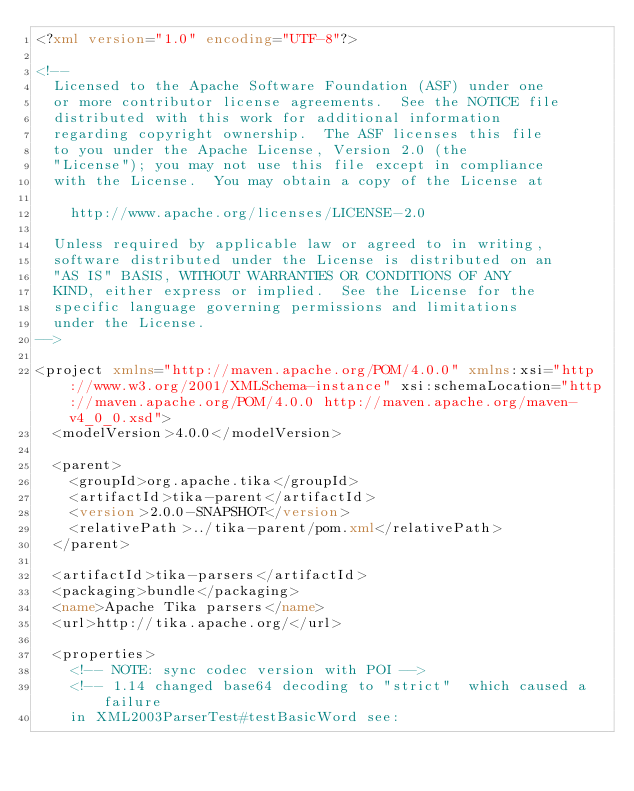Convert code to text. <code><loc_0><loc_0><loc_500><loc_500><_XML_><?xml version="1.0" encoding="UTF-8"?>

<!--
  Licensed to the Apache Software Foundation (ASF) under one
  or more contributor license agreements.  See the NOTICE file
  distributed with this work for additional information
  regarding copyright ownership.  The ASF licenses this file
  to you under the Apache License, Version 2.0 (the
  "License"); you may not use this file except in compliance
  with the License.  You may obtain a copy of the License at

    http://www.apache.org/licenses/LICENSE-2.0

  Unless required by applicable law or agreed to in writing,
  software distributed under the License is distributed on an
  "AS IS" BASIS, WITHOUT WARRANTIES OR CONDITIONS OF ANY
  KIND, either express or implied.  See the License for the
  specific language governing permissions and limitations
  under the License.
-->

<project xmlns="http://maven.apache.org/POM/4.0.0" xmlns:xsi="http://www.w3.org/2001/XMLSchema-instance" xsi:schemaLocation="http://maven.apache.org/POM/4.0.0 http://maven.apache.org/maven-v4_0_0.xsd">
  <modelVersion>4.0.0</modelVersion>

  <parent>
    <groupId>org.apache.tika</groupId>
    <artifactId>tika-parent</artifactId>
    <version>2.0.0-SNAPSHOT</version>
    <relativePath>../tika-parent/pom.xml</relativePath>
  </parent>

  <artifactId>tika-parsers</artifactId>
  <packaging>bundle</packaging>
  <name>Apache Tika parsers</name>
  <url>http://tika.apache.org/</url>

  <properties>
    <!-- NOTE: sync codec version with POI -->
    <!-- 1.14 changed base64 decoding to "strict"  which caused a failure
    in XML2003ParserTest#testBasicWord see:</code> 